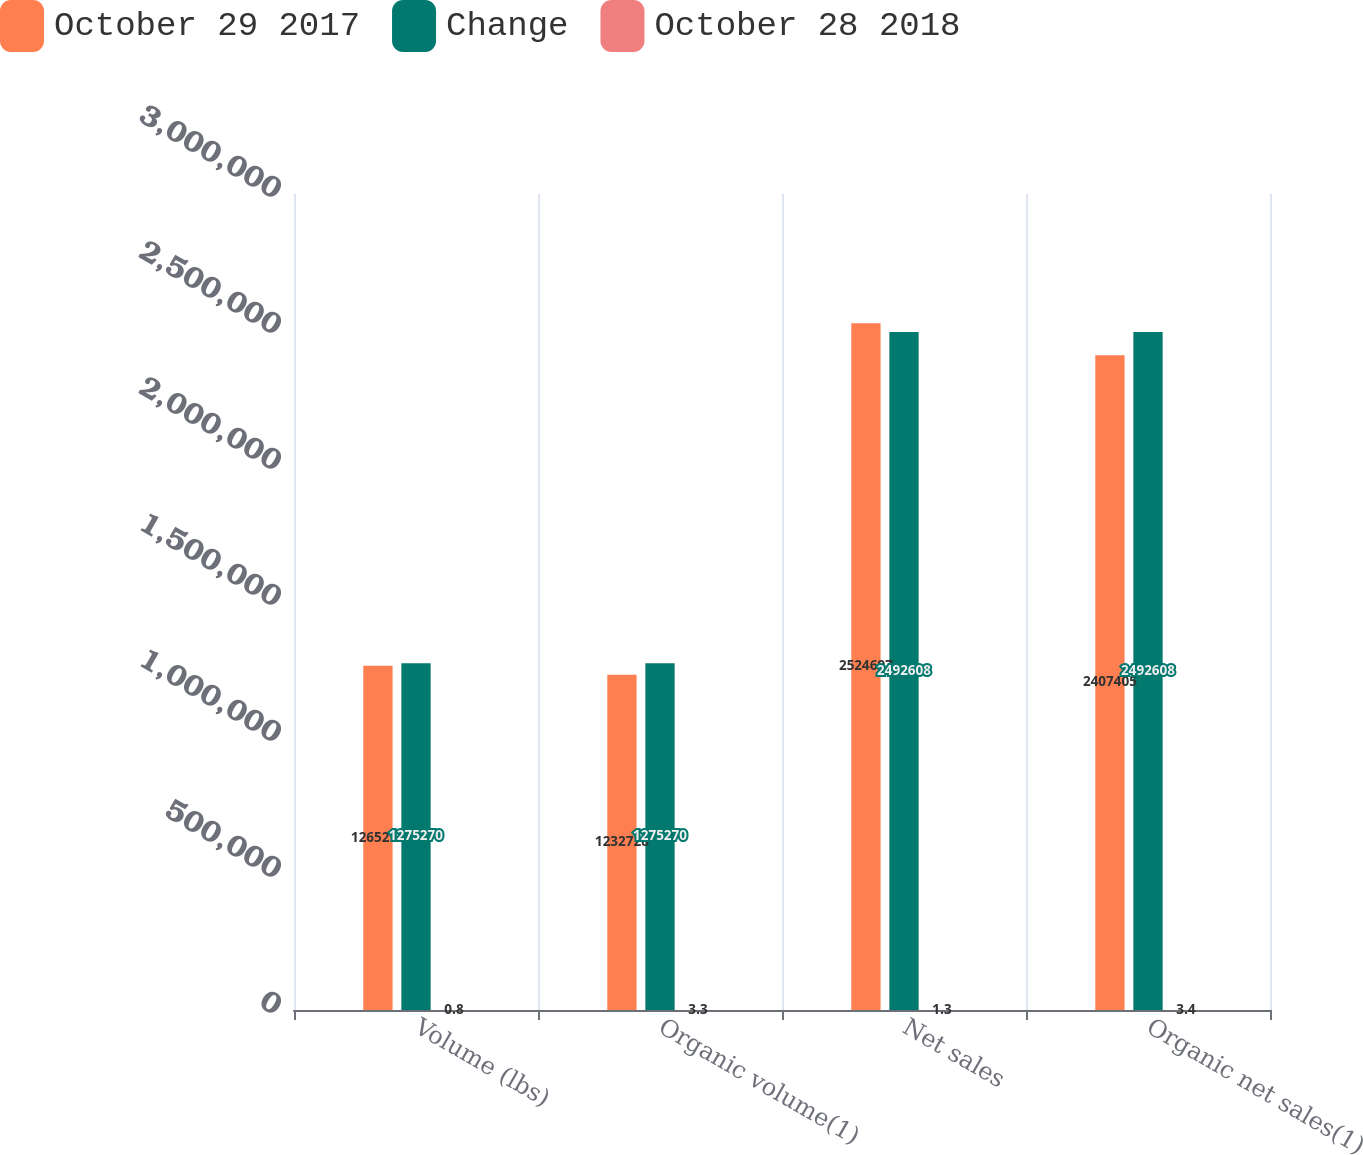Convert chart to OTSL. <chart><loc_0><loc_0><loc_500><loc_500><stacked_bar_chart><ecel><fcel>Volume (lbs)<fcel>Organic volume(1)<fcel>Net sales<fcel>Organic net sales(1)<nl><fcel>October 29 2017<fcel>1.26529e+06<fcel>1.23273e+06<fcel>2.5247e+06<fcel>2.4074e+06<nl><fcel>Change<fcel>1.27527e+06<fcel>1.27527e+06<fcel>2.49261e+06<fcel>2.49261e+06<nl><fcel>October 28 2018<fcel>0.8<fcel>3.3<fcel>1.3<fcel>3.4<nl></chart> 